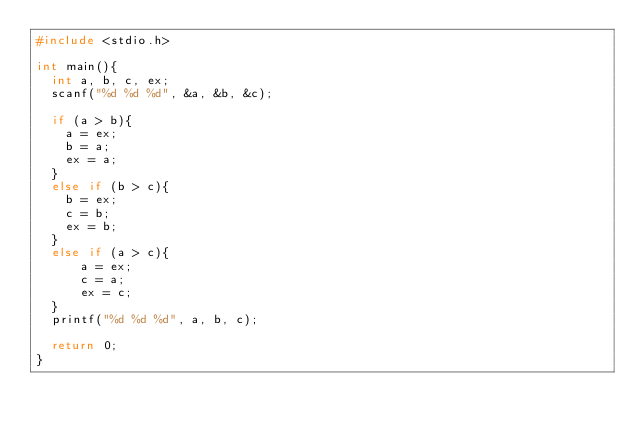<code> <loc_0><loc_0><loc_500><loc_500><_C_>#include <stdio.h>

int main(){
	int a, b, c, ex;
	scanf("%d %d %d", &a, &b, &c);
	
	if (a > b){
		a = ex;
		b = a;
		ex = a;
	}
	else if (b > c){
		b = ex;
		c = b;
		ex = b;
	}
	else if (a > c){
			a = ex;
			c = a;
			ex = c;
	}
	printf("%d %d %d", a, b, c);

	return 0;
}</code> 